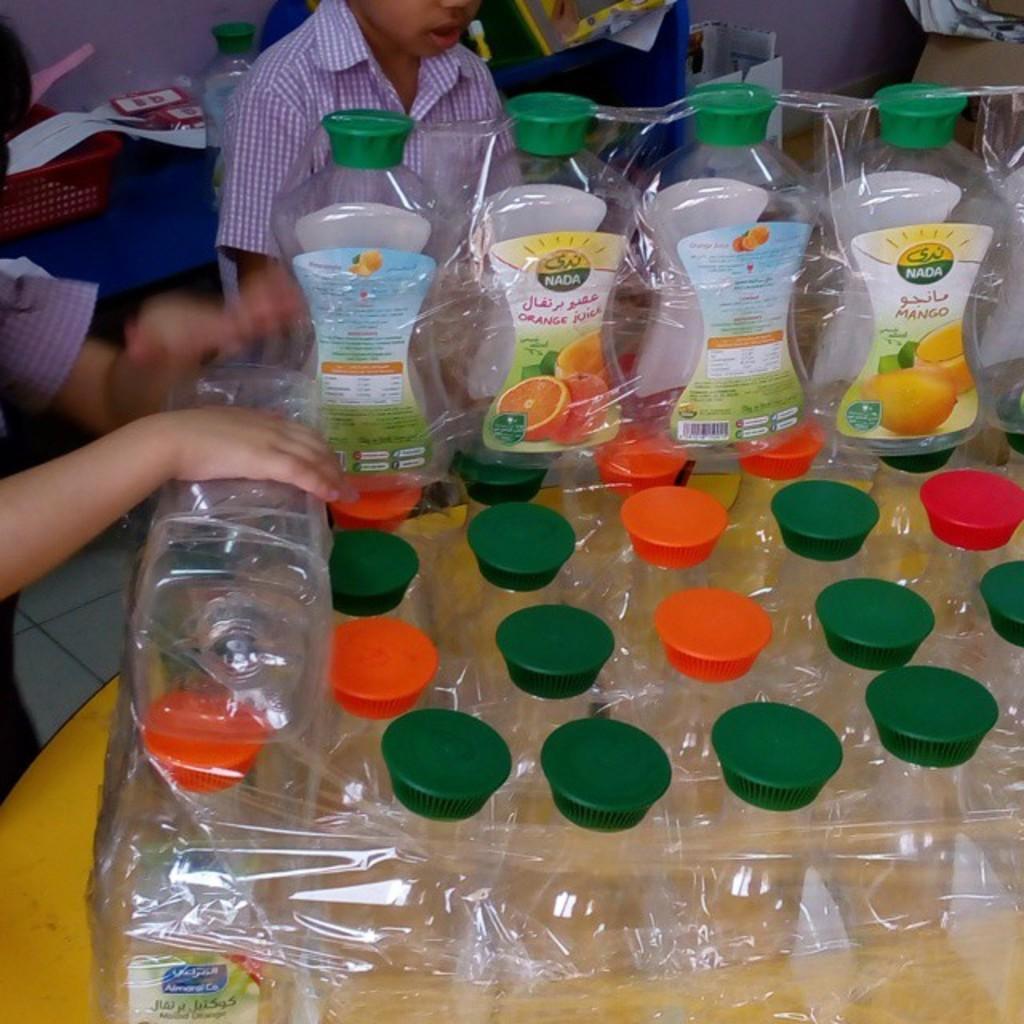Can you describe this image briefly? This is a table where a packed bottles are kept on it. In the background we can see two children who are on the left side. 